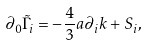<formula> <loc_0><loc_0><loc_500><loc_500>\partial _ { 0 } \tilde { \Gamma } _ { i } = - \frac { 4 } { 3 } a \partial _ { i } k + S _ { i } ,</formula> 